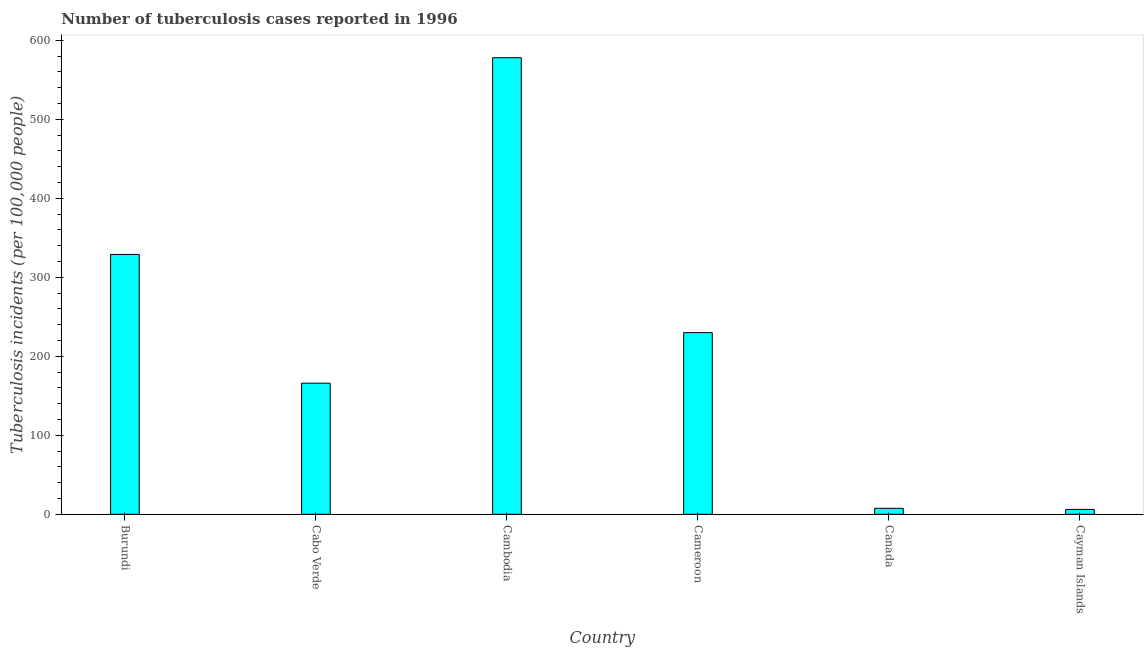What is the title of the graph?
Provide a succinct answer. Number of tuberculosis cases reported in 1996. What is the label or title of the X-axis?
Give a very brief answer. Country. What is the label or title of the Y-axis?
Offer a terse response. Tuberculosis incidents (per 100,0 people). What is the number of tuberculosis incidents in Cayman Islands?
Your answer should be very brief. 6.2. Across all countries, what is the maximum number of tuberculosis incidents?
Give a very brief answer. 578. Across all countries, what is the minimum number of tuberculosis incidents?
Provide a succinct answer. 6.2. In which country was the number of tuberculosis incidents maximum?
Your answer should be compact. Cambodia. In which country was the number of tuberculosis incidents minimum?
Keep it short and to the point. Cayman Islands. What is the sum of the number of tuberculosis incidents?
Provide a succinct answer. 1316.8. What is the difference between the number of tuberculosis incidents in Cabo Verde and Cayman Islands?
Provide a short and direct response. 159.8. What is the average number of tuberculosis incidents per country?
Offer a very short reply. 219.47. What is the median number of tuberculosis incidents?
Keep it short and to the point. 198. What is the ratio of the number of tuberculosis incidents in Cambodia to that in Cameroon?
Make the answer very short. 2.51. Is the difference between the number of tuberculosis incidents in Cameroon and Cayman Islands greater than the difference between any two countries?
Make the answer very short. No. What is the difference between the highest and the second highest number of tuberculosis incidents?
Offer a terse response. 249. Is the sum of the number of tuberculosis incidents in Cabo Verde and Cambodia greater than the maximum number of tuberculosis incidents across all countries?
Give a very brief answer. Yes. What is the difference between the highest and the lowest number of tuberculosis incidents?
Provide a short and direct response. 571.8. Are the values on the major ticks of Y-axis written in scientific E-notation?
Offer a very short reply. No. What is the Tuberculosis incidents (per 100,000 people) in Burundi?
Offer a very short reply. 329. What is the Tuberculosis incidents (per 100,000 people) in Cabo Verde?
Provide a succinct answer. 166. What is the Tuberculosis incidents (per 100,000 people) of Cambodia?
Offer a very short reply. 578. What is the Tuberculosis incidents (per 100,000 people) of Cameroon?
Your answer should be compact. 230. What is the Tuberculosis incidents (per 100,000 people) in Canada?
Ensure brevity in your answer.  7.6. What is the difference between the Tuberculosis incidents (per 100,000 people) in Burundi and Cabo Verde?
Keep it short and to the point. 163. What is the difference between the Tuberculosis incidents (per 100,000 people) in Burundi and Cambodia?
Your answer should be compact. -249. What is the difference between the Tuberculosis incidents (per 100,000 people) in Burundi and Canada?
Keep it short and to the point. 321.4. What is the difference between the Tuberculosis incidents (per 100,000 people) in Burundi and Cayman Islands?
Give a very brief answer. 322.8. What is the difference between the Tuberculosis incidents (per 100,000 people) in Cabo Verde and Cambodia?
Offer a terse response. -412. What is the difference between the Tuberculosis incidents (per 100,000 people) in Cabo Verde and Cameroon?
Offer a terse response. -64. What is the difference between the Tuberculosis incidents (per 100,000 people) in Cabo Verde and Canada?
Your answer should be compact. 158.4. What is the difference between the Tuberculosis incidents (per 100,000 people) in Cabo Verde and Cayman Islands?
Your answer should be very brief. 159.8. What is the difference between the Tuberculosis incidents (per 100,000 people) in Cambodia and Cameroon?
Your answer should be compact. 348. What is the difference between the Tuberculosis incidents (per 100,000 people) in Cambodia and Canada?
Offer a terse response. 570.4. What is the difference between the Tuberculosis incidents (per 100,000 people) in Cambodia and Cayman Islands?
Your answer should be very brief. 571.8. What is the difference between the Tuberculosis incidents (per 100,000 people) in Cameroon and Canada?
Offer a terse response. 222.4. What is the difference between the Tuberculosis incidents (per 100,000 people) in Cameroon and Cayman Islands?
Offer a very short reply. 223.8. What is the difference between the Tuberculosis incidents (per 100,000 people) in Canada and Cayman Islands?
Your answer should be compact. 1.4. What is the ratio of the Tuberculosis incidents (per 100,000 people) in Burundi to that in Cabo Verde?
Ensure brevity in your answer.  1.98. What is the ratio of the Tuberculosis incidents (per 100,000 people) in Burundi to that in Cambodia?
Offer a very short reply. 0.57. What is the ratio of the Tuberculosis incidents (per 100,000 people) in Burundi to that in Cameroon?
Give a very brief answer. 1.43. What is the ratio of the Tuberculosis incidents (per 100,000 people) in Burundi to that in Canada?
Provide a short and direct response. 43.29. What is the ratio of the Tuberculosis incidents (per 100,000 people) in Burundi to that in Cayman Islands?
Your response must be concise. 53.06. What is the ratio of the Tuberculosis incidents (per 100,000 people) in Cabo Verde to that in Cambodia?
Provide a succinct answer. 0.29. What is the ratio of the Tuberculosis incidents (per 100,000 people) in Cabo Verde to that in Cameroon?
Keep it short and to the point. 0.72. What is the ratio of the Tuberculosis incidents (per 100,000 people) in Cabo Verde to that in Canada?
Keep it short and to the point. 21.84. What is the ratio of the Tuberculosis incidents (per 100,000 people) in Cabo Verde to that in Cayman Islands?
Make the answer very short. 26.77. What is the ratio of the Tuberculosis incidents (per 100,000 people) in Cambodia to that in Cameroon?
Your answer should be very brief. 2.51. What is the ratio of the Tuberculosis incidents (per 100,000 people) in Cambodia to that in Canada?
Offer a very short reply. 76.05. What is the ratio of the Tuberculosis incidents (per 100,000 people) in Cambodia to that in Cayman Islands?
Your response must be concise. 93.23. What is the ratio of the Tuberculosis incidents (per 100,000 people) in Cameroon to that in Canada?
Your answer should be very brief. 30.26. What is the ratio of the Tuberculosis incidents (per 100,000 people) in Cameroon to that in Cayman Islands?
Your response must be concise. 37.1. What is the ratio of the Tuberculosis incidents (per 100,000 people) in Canada to that in Cayman Islands?
Offer a very short reply. 1.23. 